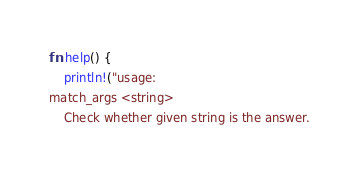Convert code to text. <code><loc_0><loc_0><loc_500><loc_500><_Rust_>fn help() {
    println!("usage:
match_args <string>
    Check whether given string is the answer.</code> 